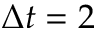<formula> <loc_0><loc_0><loc_500><loc_500>\Delta t = 2</formula> 